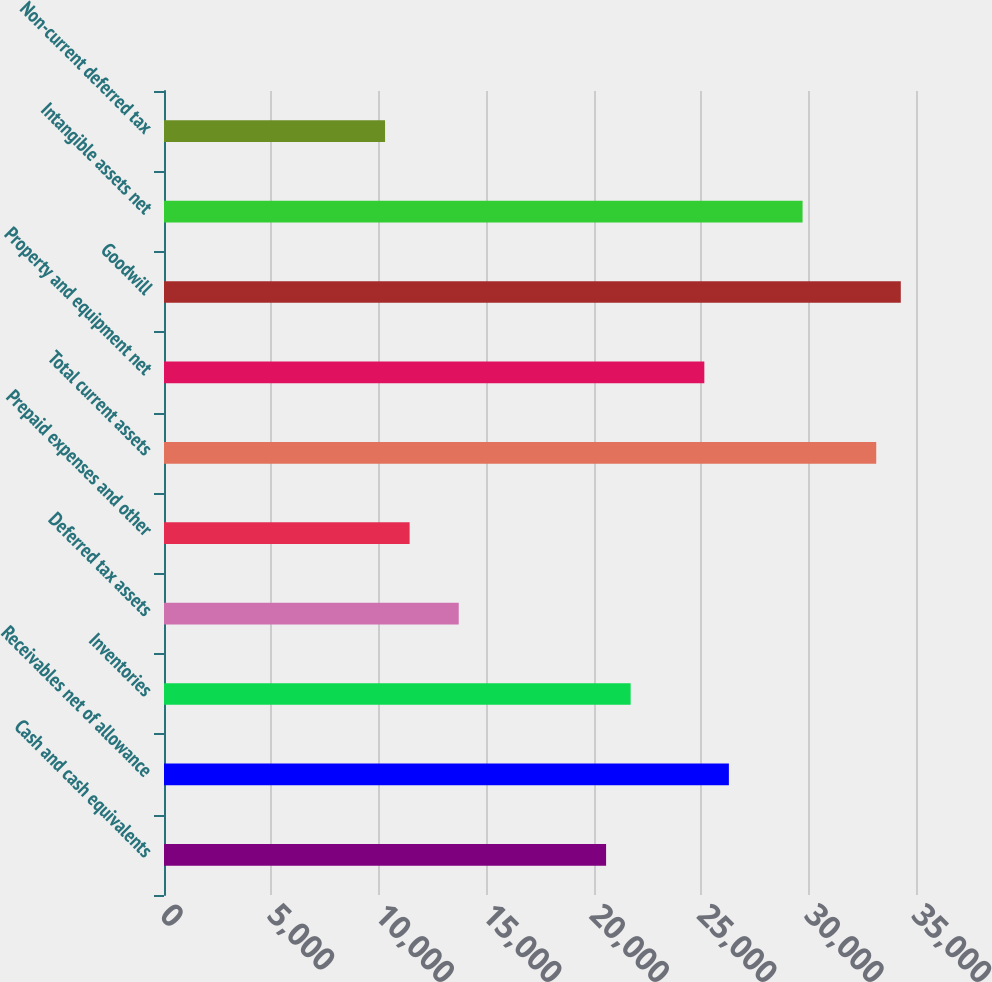<chart> <loc_0><loc_0><loc_500><loc_500><bar_chart><fcel>Cash and cash equivalents<fcel>Receivables net of allowance<fcel>Inventories<fcel>Deferred tax assets<fcel>Prepaid expenses and other<fcel>Total current assets<fcel>Property and equipment net<fcel>Goodwill<fcel>Intangible assets net<fcel>Non-current deferred tax<nl><fcel>20576.2<fcel>26291.3<fcel>21719.2<fcel>13718<fcel>11432<fcel>33149.4<fcel>25148.2<fcel>34292.4<fcel>29720.3<fcel>10289<nl></chart> 